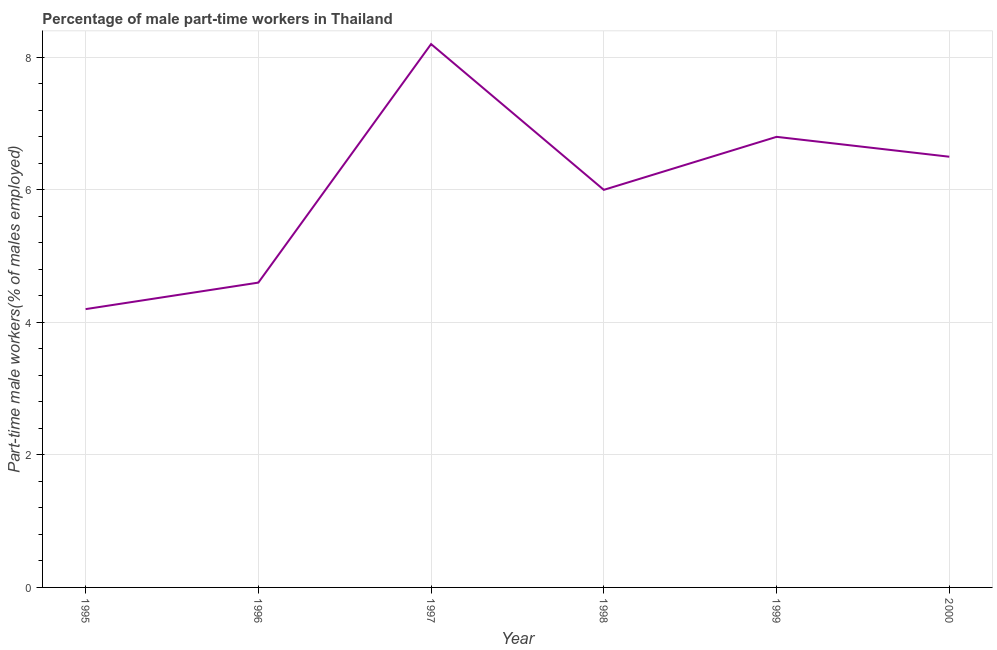What is the percentage of part-time male workers in 1997?
Keep it short and to the point. 8.2. Across all years, what is the maximum percentage of part-time male workers?
Keep it short and to the point. 8.2. Across all years, what is the minimum percentage of part-time male workers?
Make the answer very short. 4.2. In which year was the percentage of part-time male workers minimum?
Your response must be concise. 1995. What is the sum of the percentage of part-time male workers?
Your answer should be very brief. 36.3. What is the difference between the percentage of part-time male workers in 1996 and 1997?
Your answer should be compact. -3.6. What is the average percentage of part-time male workers per year?
Make the answer very short. 6.05. What is the median percentage of part-time male workers?
Offer a terse response. 6.25. In how many years, is the percentage of part-time male workers greater than 6 %?
Provide a short and direct response. 3. Do a majority of the years between 1997 and 2000 (inclusive) have percentage of part-time male workers greater than 4.4 %?
Offer a very short reply. Yes. What is the ratio of the percentage of part-time male workers in 1996 to that in 1998?
Your answer should be very brief. 0.77. Is the percentage of part-time male workers in 1996 less than that in 1997?
Ensure brevity in your answer.  Yes. Is the difference between the percentage of part-time male workers in 1996 and 2000 greater than the difference between any two years?
Offer a very short reply. No. What is the difference between the highest and the second highest percentage of part-time male workers?
Keep it short and to the point. 1.4. What is the difference between the highest and the lowest percentage of part-time male workers?
Offer a terse response. 4. How many lines are there?
Your answer should be compact. 1. How many years are there in the graph?
Your answer should be compact. 6. What is the difference between two consecutive major ticks on the Y-axis?
Provide a succinct answer. 2. Are the values on the major ticks of Y-axis written in scientific E-notation?
Ensure brevity in your answer.  No. Does the graph contain any zero values?
Offer a terse response. No. Does the graph contain grids?
Offer a terse response. Yes. What is the title of the graph?
Your answer should be compact. Percentage of male part-time workers in Thailand. What is the label or title of the X-axis?
Your answer should be very brief. Year. What is the label or title of the Y-axis?
Keep it short and to the point. Part-time male workers(% of males employed). What is the Part-time male workers(% of males employed) of 1995?
Your response must be concise. 4.2. What is the Part-time male workers(% of males employed) of 1996?
Offer a terse response. 4.6. What is the Part-time male workers(% of males employed) of 1997?
Keep it short and to the point. 8.2. What is the Part-time male workers(% of males employed) in 1998?
Your response must be concise. 6. What is the Part-time male workers(% of males employed) of 1999?
Your answer should be compact. 6.8. What is the Part-time male workers(% of males employed) of 2000?
Offer a very short reply. 6.5. What is the difference between the Part-time male workers(% of males employed) in 1995 and 1996?
Ensure brevity in your answer.  -0.4. What is the difference between the Part-time male workers(% of males employed) in 1995 and 1997?
Your answer should be very brief. -4. What is the difference between the Part-time male workers(% of males employed) in 1996 and 2000?
Make the answer very short. -1.9. What is the difference between the Part-time male workers(% of males employed) in 1997 and 1998?
Offer a terse response. 2.2. What is the difference between the Part-time male workers(% of males employed) in 1997 and 1999?
Keep it short and to the point. 1.4. What is the difference between the Part-time male workers(% of males employed) in 1997 and 2000?
Ensure brevity in your answer.  1.7. What is the difference between the Part-time male workers(% of males employed) in 1998 and 1999?
Give a very brief answer. -0.8. What is the difference between the Part-time male workers(% of males employed) in 1998 and 2000?
Give a very brief answer. -0.5. What is the difference between the Part-time male workers(% of males employed) in 1999 and 2000?
Offer a terse response. 0.3. What is the ratio of the Part-time male workers(% of males employed) in 1995 to that in 1997?
Give a very brief answer. 0.51. What is the ratio of the Part-time male workers(% of males employed) in 1995 to that in 1998?
Make the answer very short. 0.7. What is the ratio of the Part-time male workers(% of males employed) in 1995 to that in 1999?
Provide a short and direct response. 0.62. What is the ratio of the Part-time male workers(% of males employed) in 1995 to that in 2000?
Make the answer very short. 0.65. What is the ratio of the Part-time male workers(% of males employed) in 1996 to that in 1997?
Ensure brevity in your answer.  0.56. What is the ratio of the Part-time male workers(% of males employed) in 1996 to that in 1998?
Your answer should be very brief. 0.77. What is the ratio of the Part-time male workers(% of males employed) in 1996 to that in 1999?
Provide a succinct answer. 0.68. What is the ratio of the Part-time male workers(% of males employed) in 1996 to that in 2000?
Provide a short and direct response. 0.71. What is the ratio of the Part-time male workers(% of males employed) in 1997 to that in 1998?
Offer a very short reply. 1.37. What is the ratio of the Part-time male workers(% of males employed) in 1997 to that in 1999?
Offer a terse response. 1.21. What is the ratio of the Part-time male workers(% of males employed) in 1997 to that in 2000?
Keep it short and to the point. 1.26. What is the ratio of the Part-time male workers(% of males employed) in 1998 to that in 1999?
Provide a short and direct response. 0.88. What is the ratio of the Part-time male workers(% of males employed) in 1998 to that in 2000?
Provide a succinct answer. 0.92. What is the ratio of the Part-time male workers(% of males employed) in 1999 to that in 2000?
Offer a terse response. 1.05. 